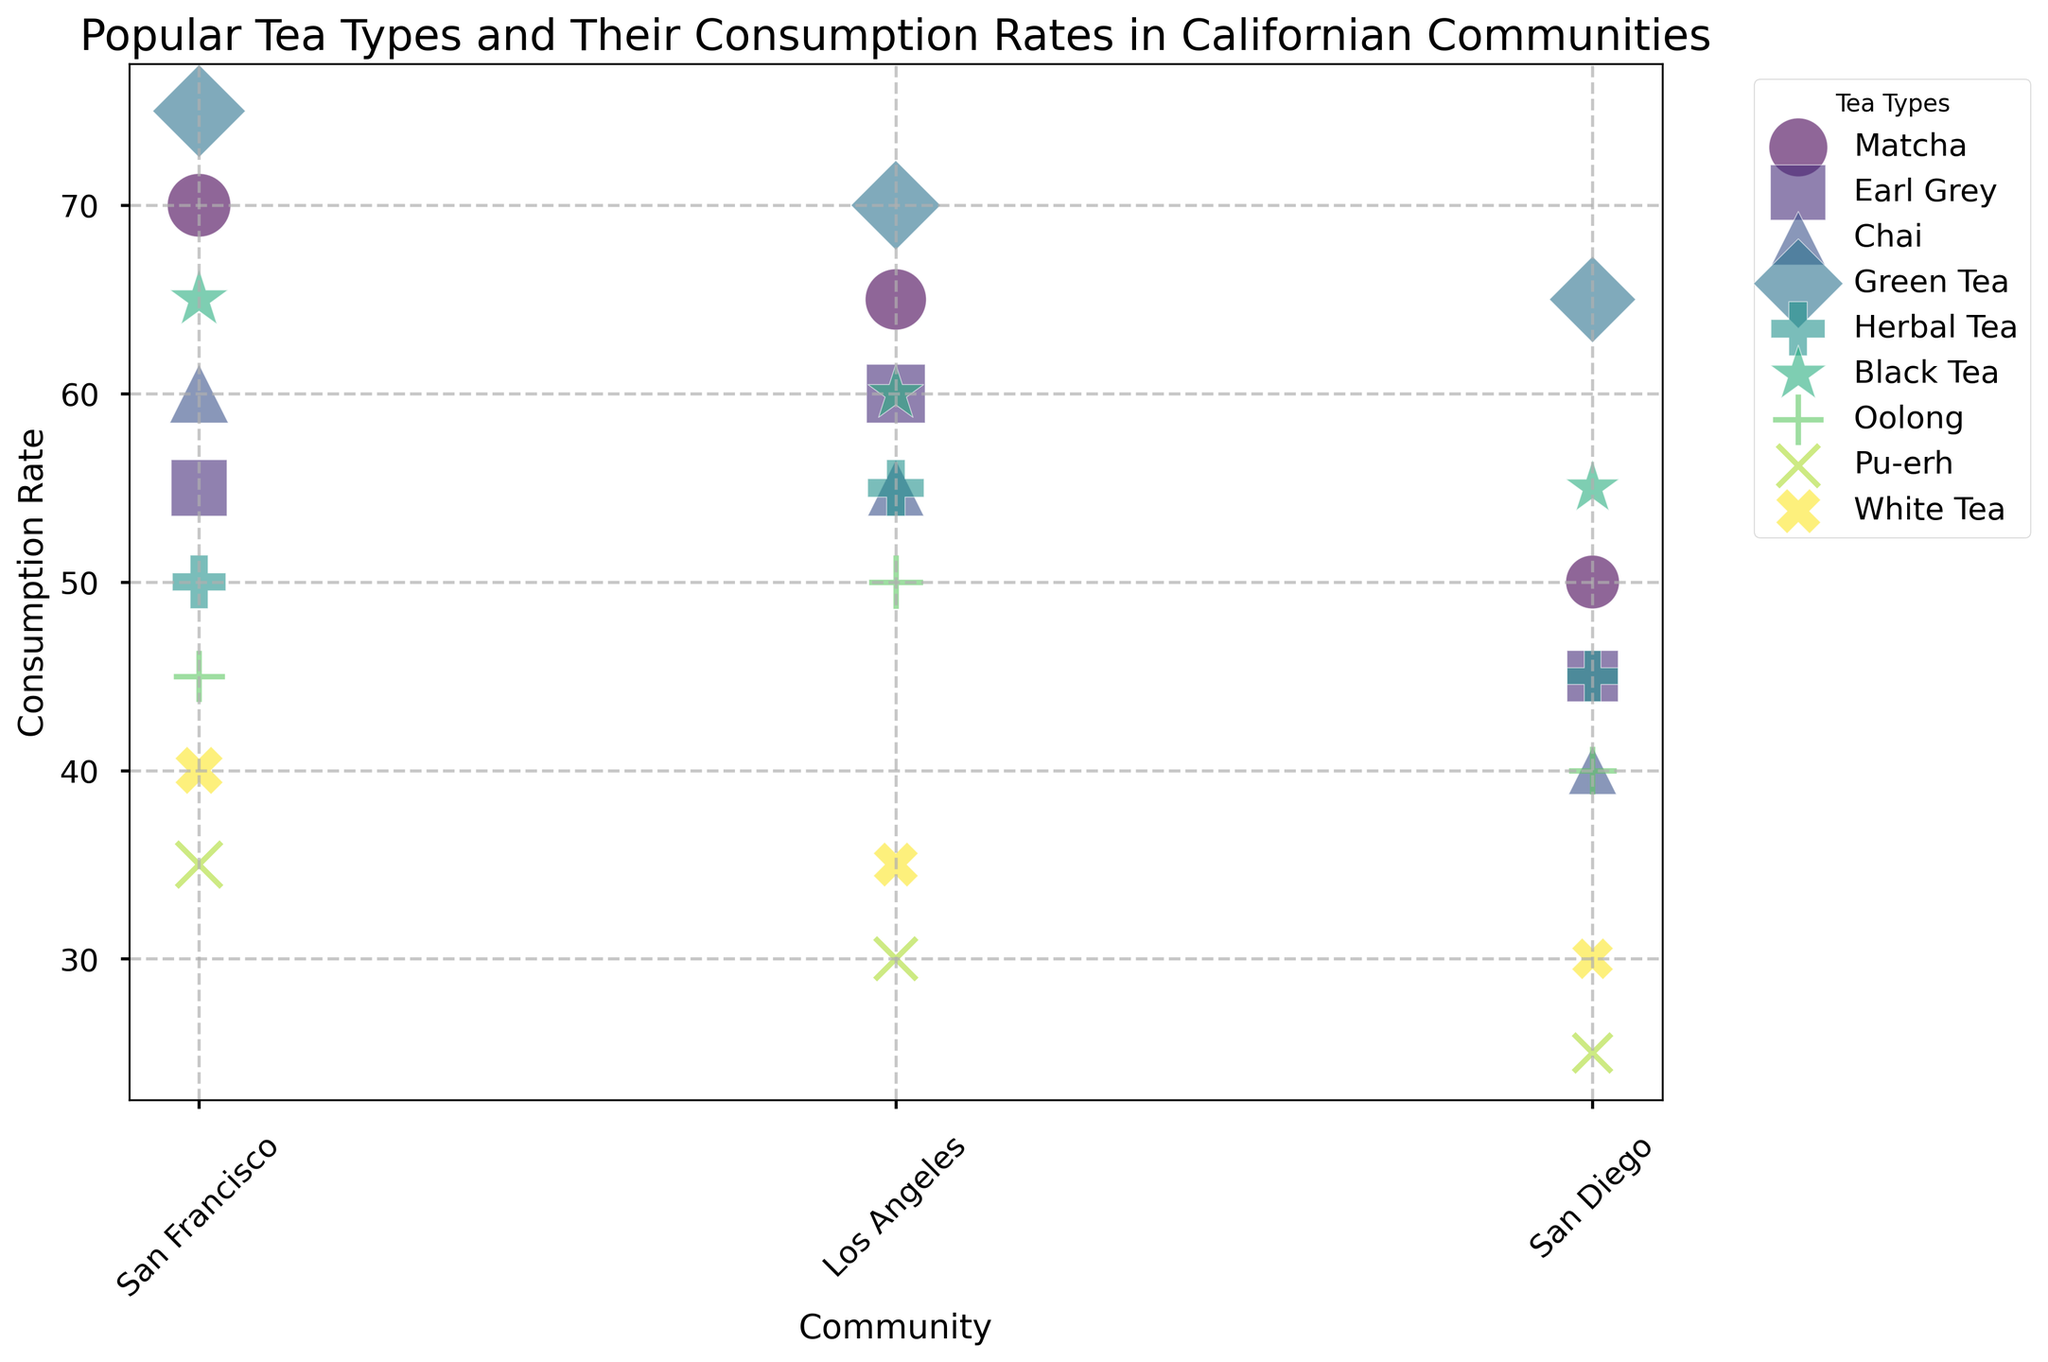What is the most consumed tea type in San Francisco? From the figure, find the bubble with the largest size (representing the highest consumption rate) for San Francisco. The largest bubble belongs to Green Tea with a consumption rate of 75.
Answer: Green Tea How does the consumption rate of Black Tea in Los Angeles compare to that in San Diego? Compare the sizes or positions of the bubbles for Black Tea between Los Angeles and San Diego. The bubble for Los Angeles (60) is slightly larger than that for San Diego (55).
Answer: Los Angeles has a higher consumption rate Which community consumes the least amount of Pu-erh tea? Examine the size of the bubbles for Pu-erh tea across all communities and identify the smallest bubble. The smallest bubble is in San Diego with a consumption rate of 25.
Answer: San Diego What's the average consumption rate of Herbal Tea across all communities? Sum the consumption rates of Herbal Tea in all communities (50 for San Francisco, 55 for Los Angeles, and 45 for San Diego) and divide by 3. The average is (50 + 55 + 45) / 3 = 50.
Answer: 50 Compare the consumption rates of Chai and Oolong in San Francisco. Which is higher? Look at the sizes or positions of the bubbles for Chai and Oolong in San Francisco. Chai's consumption rate is 60 while Oolong's is 45. Thus, Chai is higher.
Answer: Chai What tea type has the highest consumption rate in Los Angeles? Identify the largest bubble for Los Angeles. The largest bubble corresponds to Green Tea with a consumption rate of 70.
Answer: Green Tea Which tea type shows the greatest variation in consumption rates between communities? Find the tea type with the largest difference between its consumption rates across San Francisco, Los Angeles, and San Diego. Matcha ranges from 70 (San Francisco) to 50 (San Diego), which is a variation of 20.
Answer: Matcha If we combine the consumption rates of Earl Grey in all communities, what is the total? Add the consumption rates of Earl Grey in San Francisco (55), Los Angeles (60), and San Diego (45) together. The total is 55 + 60 + 45 = 160.
Answer: 160 Compare the color of the bubbles representing Herbal Tea and Green Tea. What is their difference? Identify the color shades of the bubbles for Herbal Tea and Green Tea, and note that Herbal Tea is somewhat lighter in shade compared to Green Tea.
Answer: Herbal Tea is lighter Considering only Matcha and Green Tea, which community prefers Green Tea more than Matcha? Compare the bubble sizes for Matcha and Green Tea within each community. In Los Angeles, Green Tea (70) has a higher rate than Matcha (65).
Answer: Los Angeles 